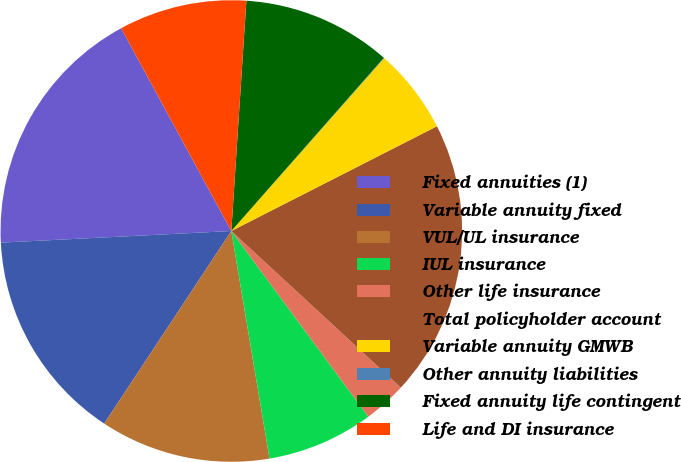Convert chart to OTSL. <chart><loc_0><loc_0><loc_500><loc_500><pie_chart><fcel>Fixed annuities (1)<fcel>Variable annuity fixed<fcel>VUL/UL insurance<fcel>IUL insurance<fcel>Other life insurance<fcel>Total policyholder account<fcel>Variable annuity GMWB<fcel>Other annuity liabilities<fcel>Fixed annuity life contingent<fcel>Life and DI insurance<nl><fcel>17.88%<fcel>14.91%<fcel>11.93%<fcel>7.47%<fcel>3.01%<fcel>19.37%<fcel>5.98%<fcel>0.03%<fcel>10.45%<fcel>8.96%<nl></chart> 